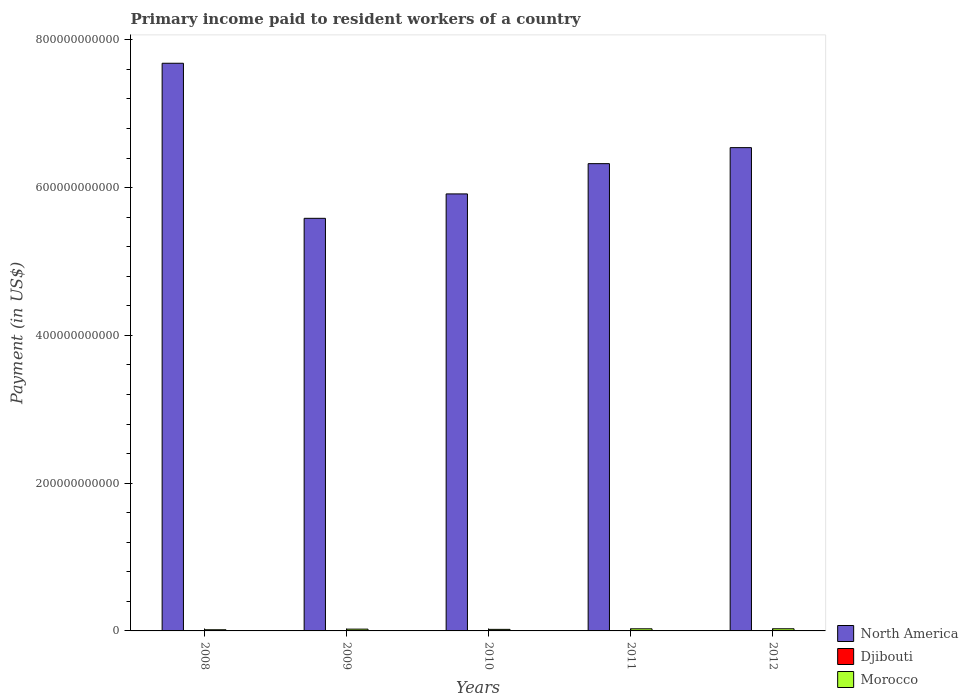How many different coloured bars are there?
Provide a succinct answer. 3. How many groups of bars are there?
Provide a succinct answer. 5. How many bars are there on the 5th tick from the left?
Make the answer very short. 3. What is the amount paid to workers in Djibouti in 2008?
Provide a short and direct response. 1.29e+07. Across all years, what is the maximum amount paid to workers in Djibouti?
Keep it short and to the point. 2.79e+07. Across all years, what is the minimum amount paid to workers in Djibouti?
Your answer should be compact. 1.29e+07. In which year was the amount paid to workers in Djibouti maximum?
Your answer should be very brief. 2011. In which year was the amount paid to workers in Morocco minimum?
Make the answer very short. 2008. What is the total amount paid to workers in North America in the graph?
Offer a terse response. 3.20e+12. What is the difference between the amount paid to workers in Morocco in 2010 and that in 2011?
Offer a very short reply. -7.46e+08. What is the difference between the amount paid to workers in Djibouti in 2008 and the amount paid to workers in Morocco in 2010?
Ensure brevity in your answer.  -2.10e+09. What is the average amount paid to workers in Djibouti per year?
Provide a short and direct response. 1.79e+07. In the year 2010, what is the difference between the amount paid to workers in Djibouti and amount paid to workers in North America?
Your answer should be compact. -5.91e+11. In how many years, is the amount paid to workers in North America greater than 560000000000 US$?
Give a very brief answer. 4. What is the ratio of the amount paid to workers in North America in 2011 to that in 2012?
Offer a very short reply. 0.97. What is the difference between the highest and the second highest amount paid to workers in Morocco?
Ensure brevity in your answer.  4.30e+07. What is the difference between the highest and the lowest amount paid to workers in Djibouti?
Give a very brief answer. 1.51e+07. In how many years, is the amount paid to workers in Morocco greater than the average amount paid to workers in Morocco taken over all years?
Your answer should be very brief. 3. What does the 2nd bar from the left in 2010 represents?
Your answer should be compact. Djibouti. How many bars are there?
Your answer should be compact. 15. Are all the bars in the graph horizontal?
Provide a short and direct response. No. What is the difference between two consecutive major ticks on the Y-axis?
Provide a short and direct response. 2.00e+11. Does the graph contain grids?
Your response must be concise. No. Where does the legend appear in the graph?
Keep it short and to the point. Bottom right. How are the legend labels stacked?
Provide a succinct answer. Vertical. What is the title of the graph?
Keep it short and to the point. Primary income paid to resident workers of a country. What is the label or title of the X-axis?
Give a very brief answer. Years. What is the label or title of the Y-axis?
Offer a very short reply. Payment (in US$). What is the Payment (in US$) in North America in 2008?
Offer a very short reply. 7.68e+11. What is the Payment (in US$) in Djibouti in 2008?
Ensure brevity in your answer.  1.29e+07. What is the Payment (in US$) of Morocco in 2008?
Make the answer very short. 1.58e+09. What is the Payment (in US$) of North America in 2009?
Offer a very short reply. 5.58e+11. What is the Payment (in US$) of Djibouti in 2009?
Give a very brief answer. 1.53e+07. What is the Payment (in US$) in Morocco in 2009?
Give a very brief answer. 2.42e+09. What is the Payment (in US$) in North America in 2010?
Keep it short and to the point. 5.91e+11. What is the Payment (in US$) in Djibouti in 2010?
Keep it short and to the point. 1.54e+07. What is the Payment (in US$) of Morocco in 2010?
Offer a very short reply. 2.11e+09. What is the Payment (in US$) in North America in 2011?
Offer a terse response. 6.32e+11. What is the Payment (in US$) in Djibouti in 2011?
Ensure brevity in your answer.  2.79e+07. What is the Payment (in US$) in Morocco in 2011?
Keep it short and to the point. 2.86e+09. What is the Payment (in US$) of North America in 2012?
Provide a short and direct response. 6.54e+11. What is the Payment (in US$) in Djibouti in 2012?
Your answer should be very brief. 1.80e+07. What is the Payment (in US$) in Morocco in 2012?
Your answer should be very brief. 2.90e+09. Across all years, what is the maximum Payment (in US$) in North America?
Your response must be concise. 7.68e+11. Across all years, what is the maximum Payment (in US$) in Djibouti?
Ensure brevity in your answer.  2.79e+07. Across all years, what is the maximum Payment (in US$) of Morocco?
Your answer should be very brief. 2.90e+09. Across all years, what is the minimum Payment (in US$) of North America?
Keep it short and to the point. 5.58e+11. Across all years, what is the minimum Payment (in US$) of Djibouti?
Make the answer very short. 1.29e+07. Across all years, what is the minimum Payment (in US$) in Morocco?
Offer a very short reply. 1.58e+09. What is the total Payment (in US$) in North America in the graph?
Your answer should be very brief. 3.20e+12. What is the total Payment (in US$) of Djibouti in the graph?
Your answer should be compact. 8.95e+07. What is the total Payment (in US$) in Morocco in the graph?
Make the answer very short. 1.19e+1. What is the difference between the Payment (in US$) of North America in 2008 and that in 2009?
Your answer should be very brief. 2.10e+11. What is the difference between the Payment (in US$) of Djibouti in 2008 and that in 2009?
Your answer should be very brief. -2.40e+06. What is the difference between the Payment (in US$) in Morocco in 2008 and that in 2009?
Provide a succinct answer. -8.40e+08. What is the difference between the Payment (in US$) in North America in 2008 and that in 2010?
Your answer should be compact. 1.77e+11. What is the difference between the Payment (in US$) in Djibouti in 2008 and that in 2010?
Provide a succinct answer. -2.52e+06. What is the difference between the Payment (in US$) in Morocco in 2008 and that in 2010?
Make the answer very short. -5.29e+08. What is the difference between the Payment (in US$) of North America in 2008 and that in 2011?
Provide a short and direct response. 1.36e+11. What is the difference between the Payment (in US$) in Djibouti in 2008 and that in 2011?
Ensure brevity in your answer.  -1.51e+07. What is the difference between the Payment (in US$) in Morocco in 2008 and that in 2011?
Make the answer very short. -1.28e+09. What is the difference between the Payment (in US$) in North America in 2008 and that in 2012?
Keep it short and to the point. 1.14e+11. What is the difference between the Payment (in US$) in Djibouti in 2008 and that in 2012?
Provide a succinct answer. -5.12e+06. What is the difference between the Payment (in US$) of Morocco in 2008 and that in 2012?
Keep it short and to the point. -1.32e+09. What is the difference between the Payment (in US$) of North America in 2009 and that in 2010?
Your response must be concise. -3.30e+1. What is the difference between the Payment (in US$) in Djibouti in 2009 and that in 2010?
Provide a short and direct response. -1.18e+05. What is the difference between the Payment (in US$) in Morocco in 2009 and that in 2010?
Give a very brief answer. 3.10e+08. What is the difference between the Payment (in US$) of North America in 2009 and that in 2011?
Keep it short and to the point. -7.40e+1. What is the difference between the Payment (in US$) in Djibouti in 2009 and that in 2011?
Ensure brevity in your answer.  -1.27e+07. What is the difference between the Payment (in US$) in Morocco in 2009 and that in 2011?
Offer a very short reply. -4.36e+08. What is the difference between the Payment (in US$) of North America in 2009 and that in 2012?
Ensure brevity in your answer.  -9.57e+1. What is the difference between the Payment (in US$) of Djibouti in 2009 and that in 2012?
Provide a short and direct response. -2.72e+06. What is the difference between the Payment (in US$) of Morocco in 2009 and that in 2012?
Your response must be concise. -4.79e+08. What is the difference between the Payment (in US$) of North America in 2010 and that in 2011?
Your answer should be very brief. -4.10e+1. What is the difference between the Payment (in US$) of Djibouti in 2010 and that in 2011?
Your answer should be very brief. -1.25e+07. What is the difference between the Payment (in US$) in Morocco in 2010 and that in 2011?
Ensure brevity in your answer.  -7.46e+08. What is the difference between the Payment (in US$) of North America in 2010 and that in 2012?
Make the answer very short. -6.26e+1. What is the difference between the Payment (in US$) in Djibouti in 2010 and that in 2012?
Give a very brief answer. -2.60e+06. What is the difference between the Payment (in US$) in Morocco in 2010 and that in 2012?
Offer a very short reply. -7.89e+08. What is the difference between the Payment (in US$) of North America in 2011 and that in 2012?
Provide a short and direct response. -2.17e+1. What is the difference between the Payment (in US$) in Djibouti in 2011 and that in 2012?
Keep it short and to the point. 9.94e+06. What is the difference between the Payment (in US$) of Morocco in 2011 and that in 2012?
Give a very brief answer. -4.30e+07. What is the difference between the Payment (in US$) of North America in 2008 and the Payment (in US$) of Djibouti in 2009?
Provide a succinct answer. 7.68e+11. What is the difference between the Payment (in US$) in North America in 2008 and the Payment (in US$) in Morocco in 2009?
Provide a short and direct response. 7.66e+11. What is the difference between the Payment (in US$) in Djibouti in 2008 and the Payment (in US$) in Morocco in 2009?
Offer a very short reply. -2.41e+09. What is the difference between the Payment (in US$) in North America in 2008 and the Payment (in US$) in Djibouti in 2010?
Offer a terse response. 7.68e+11. What is the difference between the Payment (in US$) of North America in 2008 and the Payment (in US$) of Morocco in 2010?
Your response must be concise. 7.66e+11. What is the difference between the Payment (in US$) of Djibouti in 2008 and the Payment (in US$) of Morocco in 2010?
Offer a very short reply. -2.10e+09. What is the difference between the Payment (in US$) in North America in 2008 and the Payment (in US$) in Djibouti in 2011?
Your response must be concise. 7.68e+11. What is the difference between the Payment (in US$) in North America in 2008 and the Payment (in US$) in Morocco in 2011?
Your answer should be very brief. 7.65e+11. What is the difference between the Payment (in US$) in Djibouti in 2008 and the Payment (in US$) in Morocco in 2011?
Your answer should be very brief. -2.84e+09. What is the difference between the Payment (in US$) of North America in 2008 and the Payment (in US$) of Djibouti in 2012?
Keep it short and to the point. 7.68e+11. What is the difference between the Payment (in US$) in North America in 2008 and the Payment (in US$) in Morocco in 2012?
Make the answer very short. 7.65e+11. What is the difference between the Payment (in US$) in Djibouti in 2008 and the Payment (in US$) in Morocco in 2012?
Your answer should be very brief. -2.89e+09. What is the difference between the Payment (in US$) in North America in 2009 and the Payment (in US$) in Djibouti in 2010?
Ensure brevity in your answer.  5.58e+11. What is the difference between the Payment (in US$) in North America in 2009 and the Payment (in US$) in Morocco in 2010?
Make the answer very short. 5.56e+11. What is the difference between the Payment (in US$) in Djibouti in 2009 and the Payment (in US$) in Morocco in 2010?
Make the answer very short. -2.09e+09. What is the difference between the Payment (in US$) of North America in 2009 and the Payment (in US$) of Djibouti in 2011?
Offer a terse response. 5.58e+11. What is the difference between the Payment (in US$) of North America in 2009 and the Payment (in US$) of Morocco in 2011?
Provide a succinct answer. 5.56e+11. What is the difference between the Payment (in US$) in Djibouti in 2009 and the Payment (in US$) in Morocco in 2011?
Offer a terse response. -2.84e+09. What is the difference between the Payment (in US$) in North America in 2009 and the Payment (in US$) in Djibouti in 2012?
Make the answer very short. 5.58e+11. What is the difference between the Payment (in US$) of North America in 2009 and the Payment (in US$) of Morocco in 2012?
Keep it short and to the point. 5.56e+11. What is the difference between the Payment (in US$) in Djibouti in 2009 and the Payment (in US$) in Morocco in 2012?
Offer a terse response. -2.88e+09. What is the difference between the Payment (in US$) of North America in 2010 and the Payment (in US$) of Djibouti in 2011?
Provide a short and direct response. 5.91e+11. What is the difference between the Payment (in US$) in North America in 2010 and the Payment (in US$) in Morocco in 2011?
Provide a short and direct response. 5.89e+11. What is the difference between the Payment (in US$) in Djibouti in 2010 and the Payment (in US$) in Morocco in 2011?
Offer a terse response. -2.84e+09. What is the difference between the Payment (in US$) in North America in 2010 and the Payment (in US$) in Djibouti in 2012?
Provide a short and direct response. 5.91e+11. What is the difference between the Payment (in US$) in North America in 2010 and the Payment (in US$) in Morocco in 2012?
Provide a succinct answer. 5.89e+11. What is the difference between the Payment (in US$) in Djibouti in 2010 and the Payment (in US$) in Morocco in 2012?
Your response must be concise. -2.88e+09. What is the difference between the Payment (in US$) of North America in 2011 and the Payment (in US$) of Djibouti in 2012?
Your response must be concise. 6.32e+11. What is the difference between the Payment (in US$) of North America in 2011 and the Payment (in US$) of Morocco in 2012?
Your response must be concise. 6.30e+11. What is the difference between the Payment (in US$) in Djibouti in 2011 and the Payment (in US$) in Morocco in 2012?
Your answer should be very brief. -2.87e+09. What is the average Payment (in US$) of North America per year?
Your response must be concise. 6.41e+11. What is the average Payment (in US$) in Djibouti per year?
Make the answer very short. 1.79e+07. What is the average Payment (in US$) of Morocco per year?
Your answer should be compact. 2.37e+09. In the year 2008, what is the difference between the Payment (in US$) of North America and Payment (in US$) of Djibouti?
Ensure brevity in your answer.  7.68e+11. In the year 2008, what is the difference between the Payment (in US$) of North America and Payment (in US$) of Morocco?
Keep it short and to the point. 7.67e+11. In the year 2008, what is the difference between the Payment (in US$) of Djibouti and Payment (in US$) of Morocco?
Provide a succinct answer. -1.57e+09. In the year 2009, what is the difference between the Payment (in US$) of North America and Payment (in US$) of Djibouti?
Your answer should be very brief. 5.58e+11. In the year 2009, what is the difference between the Payment (in US$) in North America and Payment (in US$) in Morocco?
Make the answer very short. 5.56e+11. In the year 2009, what is the difference between the Payment (in US$) in Djibouti and Payment (in US$) in Morocco?
Give a very brief answer. -2.41e+09. In the year 2010, what is the difference between the Payment (in US$) of North America and Payment (in US$) of Djibouti?
Provide a succinct answer. 5.91e+11. In the year 2010, what is the difference between the Payment (in US$) in North America and Payment (in US$) in Morocco?
Give a very brief answer. 5.89e+11. In the year 2010, what is the difference between the Payment (in US$) in Djibouti and Payment (in US$) in Morocco?
Your answer should be very brief. -2.09e+09. In the year 2011, what is the difference between the Payment (in US$) of North America and Payment (in US$) of Djibouti?
Keep it short and to the point. 6.32e+11. In the year 2011, what is the difference between the Payment (in US$) of North America and Payment (in US$) of Morocco?
Provide a succinct answer. 6.30e+11. In the year 2011, what is the difference between the Payment (in US$) in Djibouti and Payment (in US$) in Morocco?
Your answer should be very brief. -2.83e+09. In the year 2012, what is the difference between the Payment (in US$) of North America and Payment (in US$) of Djibouti?
Your answer should be very brief. 6.54e+11. In the year 2012, what is the difference between the Payment (in US$) of North America and Payment (in US$) of Morocco?
Make the answer very short. 6.51e+11. In the year 2012, what is the difference between the Payment (in US$) of Djibouti and Payment (in US$) of Morocco?
Provide a short and direct response. -2.88e+09. What is the ratio of the Payment (in US$) in North America in 2008 to that in 2009?
Your answer should be very brief. 1.38. What is the ratio of the Payment (in US$) of Djibouti in 2008 to that in 2009?
Make the answer very short. 0.84. What is the ratio of the Payment (in US$) in Morocco in 2008 to that in 2009?
Provide a succinct answer. 0.65. What is the ratio of the Payment (in US$) of North America in 2008 to that in 2010?
Your answer should be very brief. 1.3. What is the ratio of the Payment (in US$) of Djibouti in 2008 to that in 2010?
Ensure brevity in your answer.  0.84. What is the ratio of the Payment (in US$) of Morocco in 2008 to that in 2010?
Offer a terse response. 0.75. What is the ratio of the Payment (in US$) in North America in 2008 to that in 2011?
Your response must be concise. 1.21. What is the ratio of the Payment (in US$) of Djibouti in 2008 to that in 2011?
Your answer should be compact. 0.46. What is the ratio of the Payment (in US$) in Morocco in 2008 to that in 2011?
Provide a succinct answer. 0.55. What is the ratio of the Payment (in US$) of North America in 2008 to that in 2012?
Give a very brief answer. 1.17. What is the ratio of the Payment (in US$) of Djibouti in 2008 to that in 2012?
Your answer should be very brief. 0.72. What is the ratio of the Payment (in US$) in Morocco in 2008 to that in 2012?
Make the answer very short. 0.55. What is the ratio of the Payment (in US$) of North America in 2009 to that in 2010?
Your answer should be compact. 0.94. What is the ratio of the Payment (in US$) in Djibouti in 2009 to that in 2010?
Your response must be concise. 0.99. What is the ratio of the Payment (in US$) in Morocco in 2009 to that in 2010?
Your answer should be compact. 1.15. What is the ratio of the Payment (in US$) of North America in 2009 to that in 2011?
Your answer should be very brief. 0.88. What is the ratio of the Payment (in US$) in Djibouti in 2009 to that in 2011?
Your response must be concise. 0.55. What is the ratio of the Payment (in US$) in Morocco in 2009 to that in 2011?
Give a very brief answer. 0.85. What is the ratio of the Payment (in US$) in North America in 2009 to that in 2012?
Provide a succinct answer. 0.85. What is the ratio of the Payment (in US$) in Djibouti in 2009 to that in 2012?
Your answer should be very brief. 0.85. What is the ratio of the Payment (in US$) of Morocco in 2009 to that in 2012?
Ensure brevity in your answer.  0.83. What is the ratio of the Payment (in US$) in North America in 2010 to that in 2011?
Your answer should be compact. 0.94. What is the ratio of the Payment (in US$) in Djibouti in 2010 to that in 2011?
Your response must be concise. 0.55. What is the ratio of the Payment (in US$) in Morocco in 2010 to that in 2011?
Offer a very short reply. 0.74. What is the ratio of the Payment (in US$) in North America in 2010 to that in 2012?
Provide a short and direct response. 0.9. What is the ratio of the Payment (in US$) in Djibouti in 2010 to that in 2012?
Ensure brevity in your answer.  0.86. What is the ratio of the Payment (in US$) in Morocco in 2010 to that in 2012?
Provide a succinct answer. 0.73. What is the ratio of the Payment (in US$) in North America in 2011 to that in 2012?
Your answer should be compact. 0.97. What is the ratio of the Payment (in US$) in Djibouti in 2011 to that in 2012?
Your answer should be very brief. 1.55. What is the ratio of the Payment (in US$) of Morocco in 2011 to that in 2012?
Make the answer very short. 0.99. What is the difference between the highest and the second highest Payment (in US$) in North America?
Offer a very short reply. 1.14e+11. What is the difference between the highest and the second highest Payment (in US$) of Djibouti?
Give a very brief answer. 9.94e+06. What is the difference between the highest and the second highest Payment (in US$) in Morocco?
Give a very brief answer. 4.30e+07. What is the difference between the highest and the lowest Payment (in US$) of North America?
Your answer should be very brief. 2.10e+11. What is the difference between the highest and the lowest Payment (in US$) in Djibouti?
Offer a very short reply. 1.51e+07. What is the difference between the highest and the lowest Payment (in US$) in Morocco?
Offer a very short reply. 1.32e+09. 